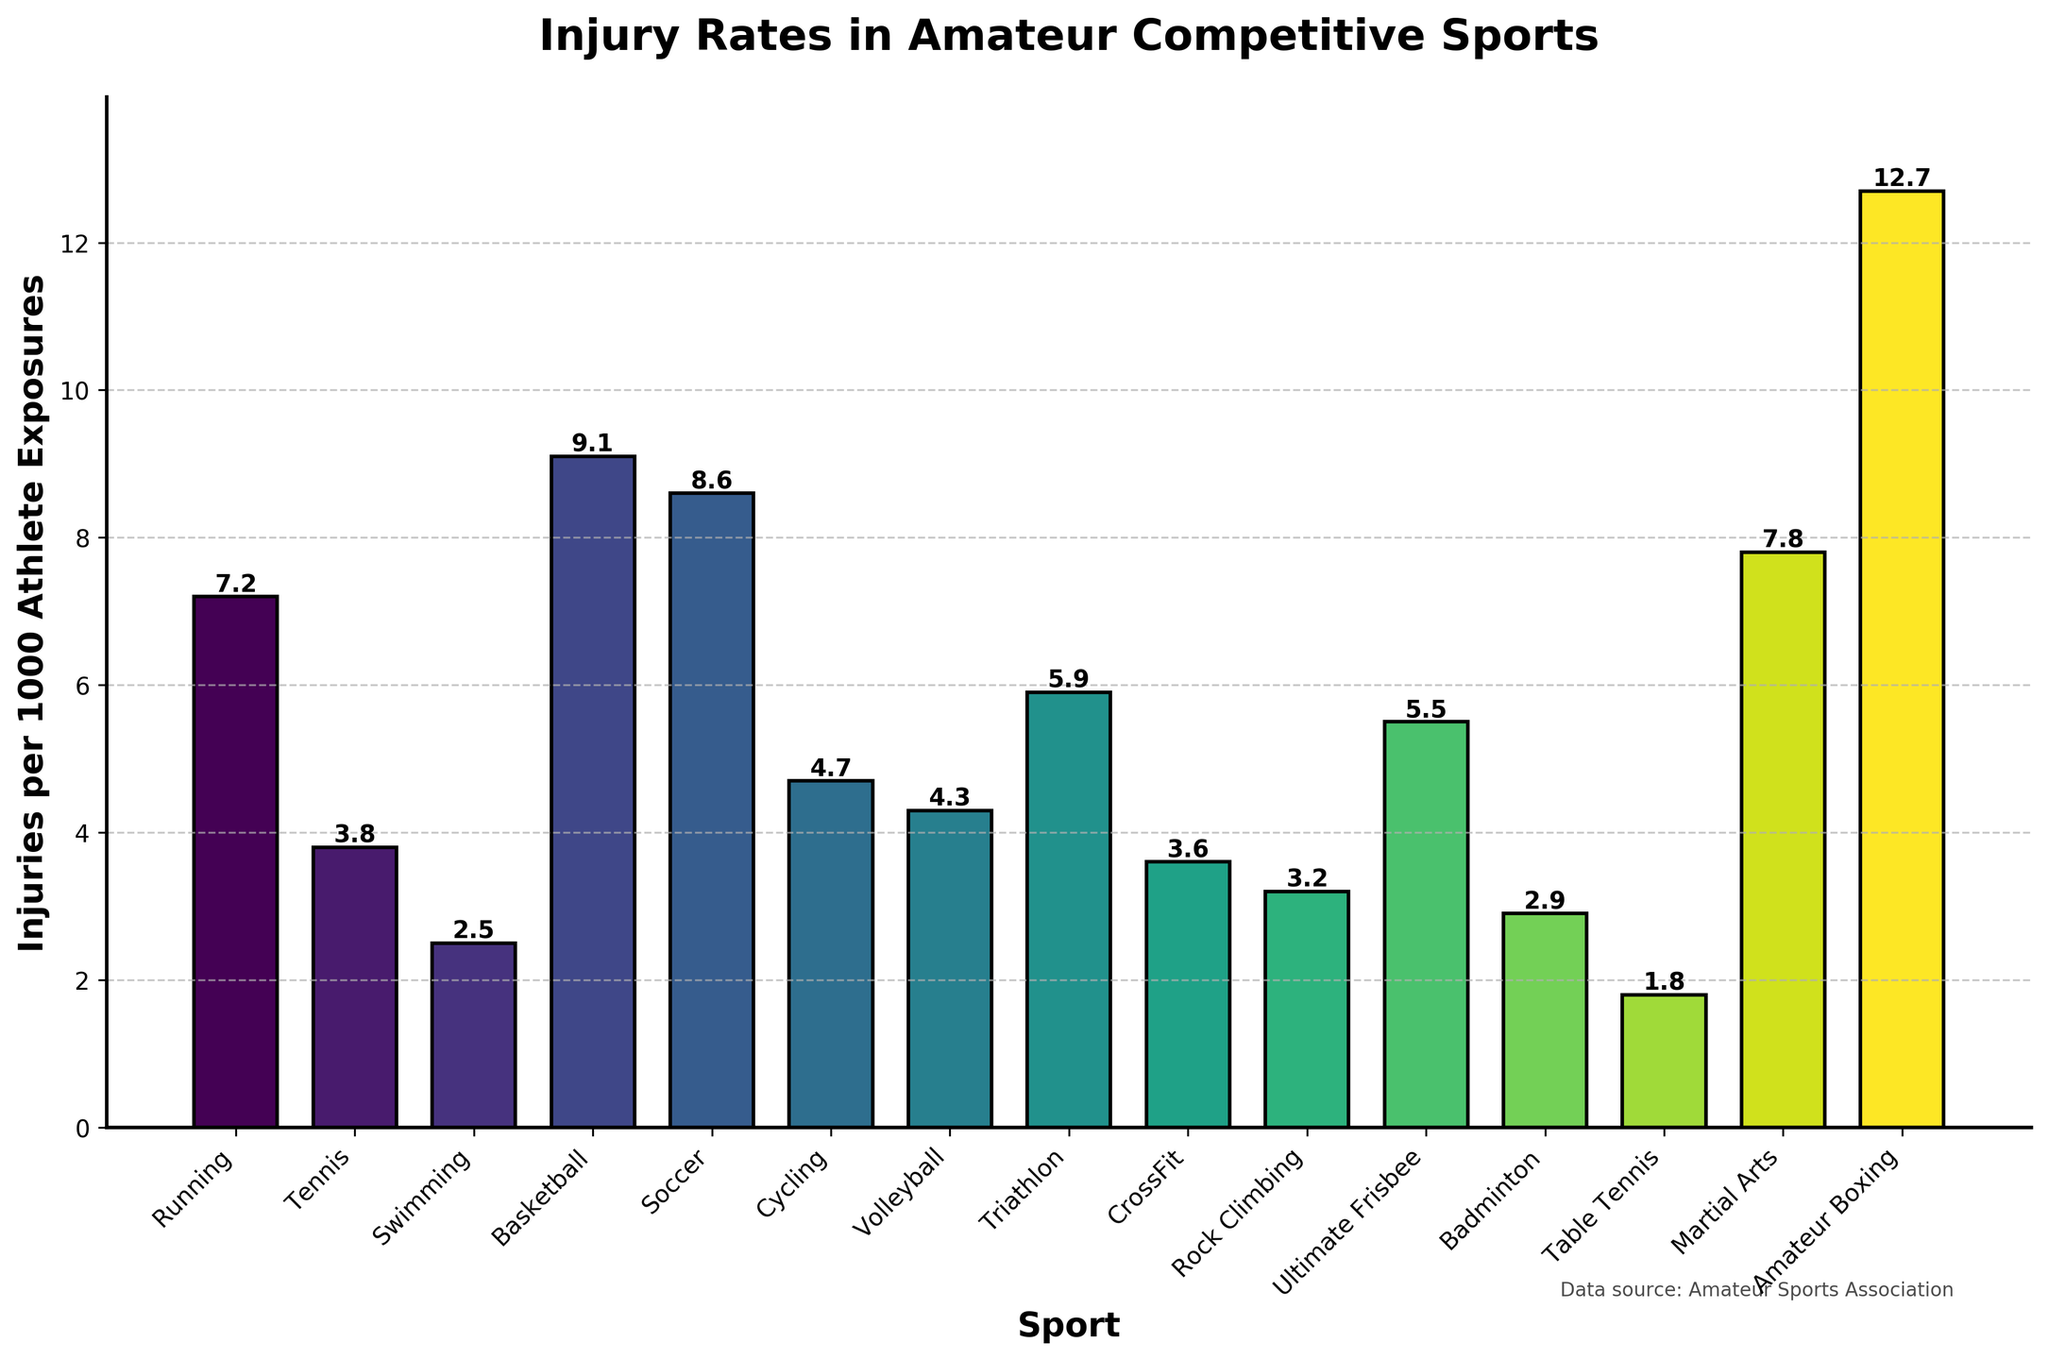What sport has the highest injury rate? To determine the sport with the highest injury rate, look for the tallest bar in the chart. The tallest bar represents Amateur Boxing, corresponding to 12.7 injuries per 1000 athlete exposures.
Answer: Amateur Boxing Which sport has a lower injury rate, Tennis or Volleyball? Compare the bar heights for Tennis and Volleyball. Tennis has an injury rate of 3.8, while Volleyball has an injury rate of 4.3.
Answer: Tennis What is the range of injury rates in all the sports? To find the range, subtract the minimum injury rate from the maximum injury rate. The maximum is 12.7 (Amateur Boxing), and the minimum is 1.8 (Table Tennis). So, the range is 12.7 - 1.8.
Answer: 10.9 How many sports have an injury rate above 5? Count the bars that are higher than the 5.0 mark on the y-axis. There are 7 sports: Basketball, Running, Soccer, Amateur Boxing, Martial Arts, Triathlon, and Ultimate Frisbee.
Answer: 7 What is the combined injury rate of Soccer and Triathlon? Find the rates for Soccer (8.6) and Triathlon (5.9), then add them together: 8.6 + 5.9 = 14.5.
Answer: 14.5 Which sport is safer, Running or Martial Arts, based on the injury rate? Compare the heights of the bars for Running and Martial Arts. Running has an injury rate of 7.2, while Martial Arts has a rate of 7.8.
Answer: Running What is the average injury rate across all the competitive sports? Sum all the injury rates and divide by the total number of sports. The rates are: 7.2, 3.8, 2.5, 9.1, 8.6, 4.7, 4.3, 5.9, 3.6, 3.2, 5.5, 2.9, 1.8, 7.8, 12.7. The sum is 83.6, and there are 15 sports. So, the average is 83.6 / 15.
Answer: 5.57 Is the injury rate of CrossFit higher or lower than the median injury rate of all the sports? To find the median, list the injury rates in numerical order and find the middle value. Ordered rates: 1.8, 2.5, 2.9, 3.2, 3.6, 3.8, 4.3, 4.7, 5.5, 5.9, 7.2, 7.8, 8.6, 9.1, 12.7. The middle value (median) is 4.7. CrossFit has an injury rate of 3.6, which is lower than 4.7.
Answer: Lower 